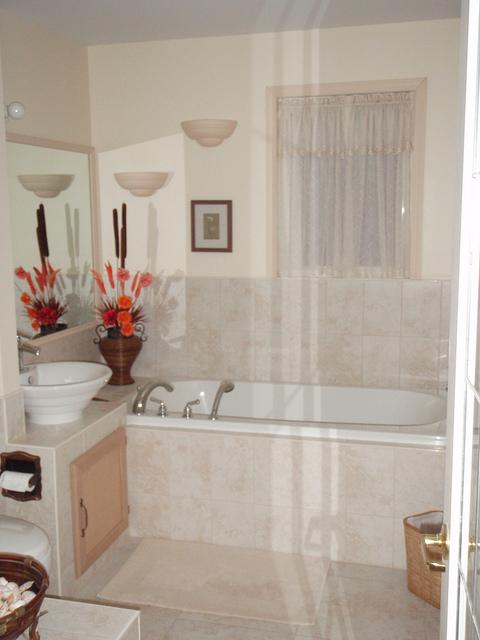What color are the flowers?
Short answer required. Red. What is on the floor next to the sink?
Short answer required. Rug. Which room of the house if pictured in this photo?
Short answer required. Bathroom. Is there toilet paper?
Be succinct. Yes. What color is the sliding glass door handle?
Answer briefly. Gold. 